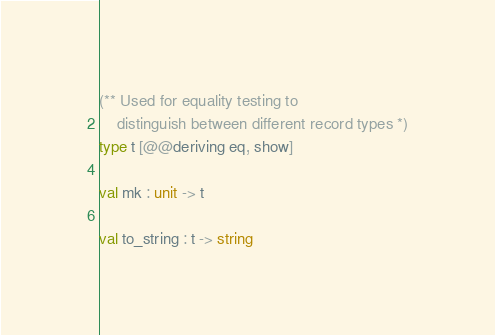<code> <loc_0><loc_0><loc_500><loc_500><_OCaml_>(** Used for equality testing to
    distinguish between different record types *)
type t [@@deriving eq, show]

val mk : unit -> t

val to_string : t -> string
</code> 